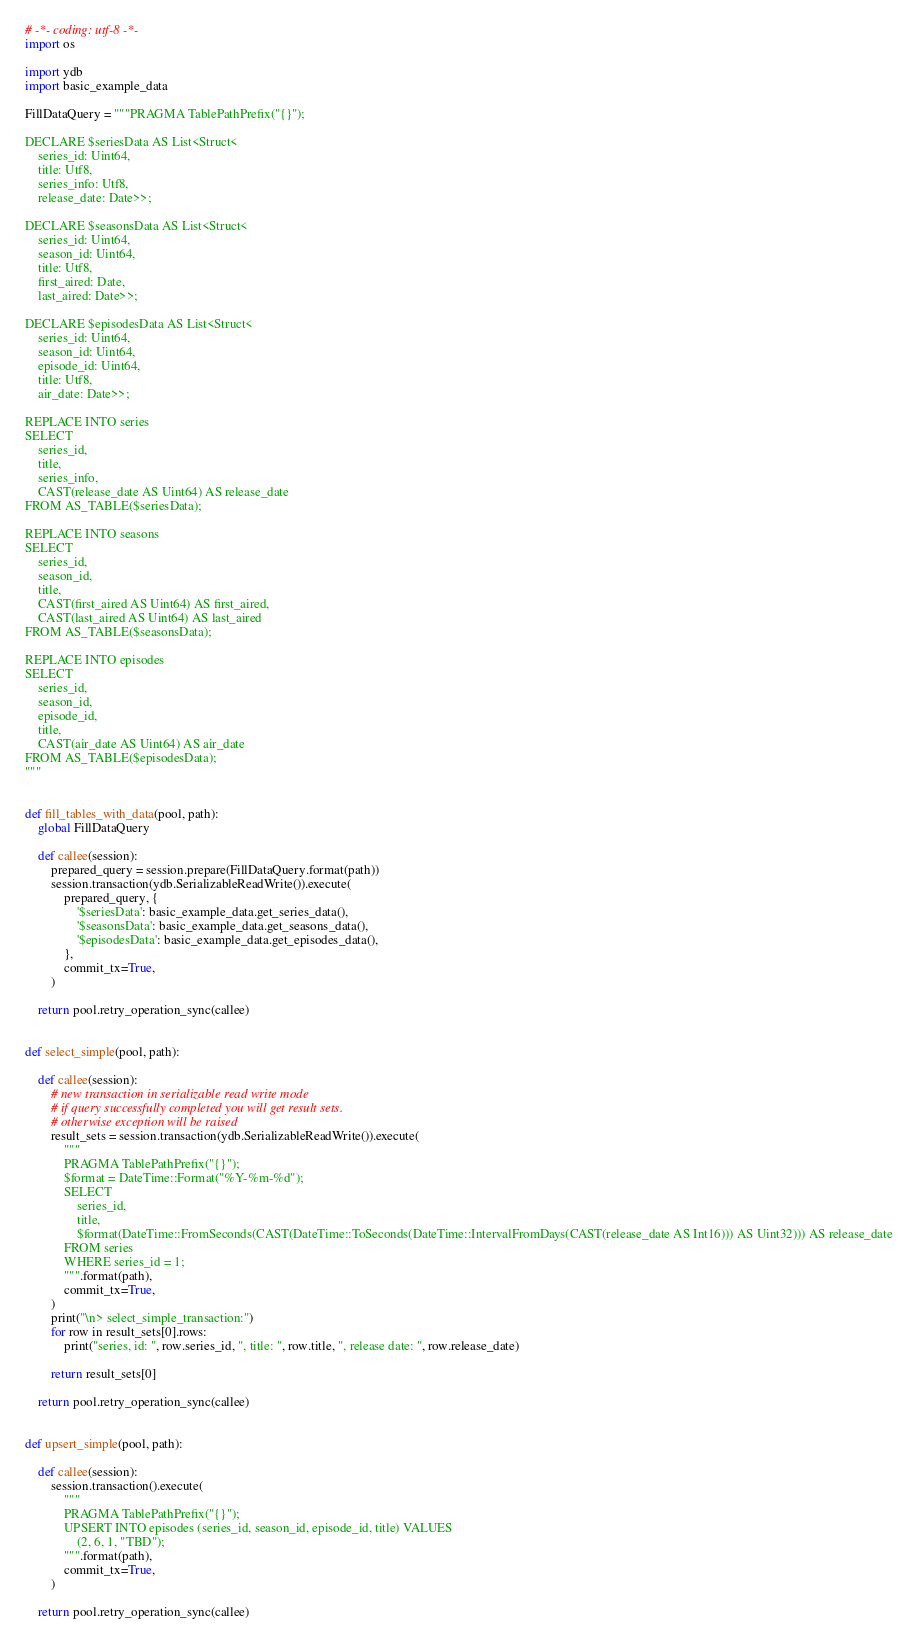Convert code to text. <code><loc_0><loc_0><loc_500><loc_500><_Python_># -*- coding: utf-8 -*-
import os

import ydb
import basic_example_data

FillDataQuery = """PRAGMA TablePathPrefix("{}");

DECLARE $seriesData AS List<Struct<
    series_id: Uint64,
    title: Utf8,
    series_info: Utf8,
    release_date: Date>>;

DECLARE $seasonsData AS List<Struct<
    series_id: Uint64,
    season_id: Uint64,
    title: Utf8,
    first_aired: Date,
    last_aired: Date>>;

DECLARE $episodesData AS List<Struct<
    series_id: Uint64,
    season_id: Uint64,
    episode_id: Uint64,
    title: Utf8,
    air_date: Date>>;

REPLACE INTO series
SELECT
    series_id,
    title,
    series_info,
    CAST(release_date AS Uint64) AS release_date
FROM AS_TABLE($seriesData);

REPLACE INTO seasons
SELECT
    series_id,
    season_id,
    title,
    CAST(first_aired AS Uint64) AS first_aired,
    CAST(last_aired AS Uint64) AS last_aired
FROM AS_TABLE($seasonsData);

REPLACE INTO episodes
SELECT
    series_id,
    season_id,
    episode_id,
    title,
    CAST(air_date AS Uint64) AS air_date
FROM AS_TABLE($episodesData);
"""


def fill_tables_with_data(pool, path):
    global FillDataQuery

    def callee(session):
        prepared_query = session.prepare(FillDataQuery.format(path))
        session.transaction(ydb.SerializableReadWrite()).execute(
            prepared_query, {
                '$seriesData': basic_example_data.get_series_data(),
                '$seasonsData': basic_example_data.get_seasons_data(),
                '$episodesData': basic_example_data.get_episodes_data(),
            },
            commit_tx=True,
        )

    return pool.retry_operation_sync(callee)


def select_simple(pool, path):

    def callee(session):
        # new transaction in serializable read write mode
        # if query successfully completed you will get result sets.
        # otherwise exception will be raised
        result_sets = session.transaction(ydb.SerializableReadWrite()).execute(
            """
            PRAGMA TablePathPrefix("{}");
            $format = DateTime::Format("%Y-%m-%d");
            SELECT
                series_id,
                title,
                $format(DateTime::FromSeconds(CAST(DateTime::ToSeconds(DateTime::IntervalFromDays(CAST(release_date AS Int16))) AS Uint32))) AS release_date
            FROM series
            WHERE series_id = 1;
            """.format(path),
            commit_tx=True,
        )
        print("\n> select_simple_transaction:")
        for row in result_sets[0].rows:
            print("series, id: ", row.series_id, ", title: ", row.title, ", release date: ", row.release_date)

        return result_sets[0]

    return pool.retry_operation_sync(callee)


def upsert_simple(pool, path):

    def callee(session):
        session.transaction().execute(
            """
            PRAGMA TablePathPrefix("{}");
            UPSERT INTO episodes (series_id, season_id, episode_id, title) VALUES
                (2, 6, 1, "TBD");
            """.format(path),
            commit_tx=True,
        )

    return pool.retry_operation_sync(callee)

</code> 